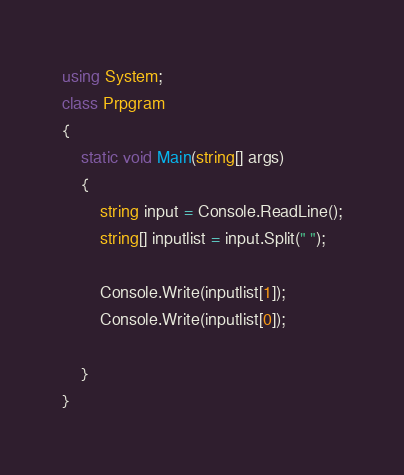<code> <loc_0><loc_0><loc_500><loc_500><_C#_>using System;
class Prpgram
{
    static void Main(string[] args)
    {
        string input = Console.ReadLine();
        string[] inputlist = input.Split(" ");

        Console.Write(inputlist[1]);
        Console.Write(inputlist[0]);

    }
}</code> 